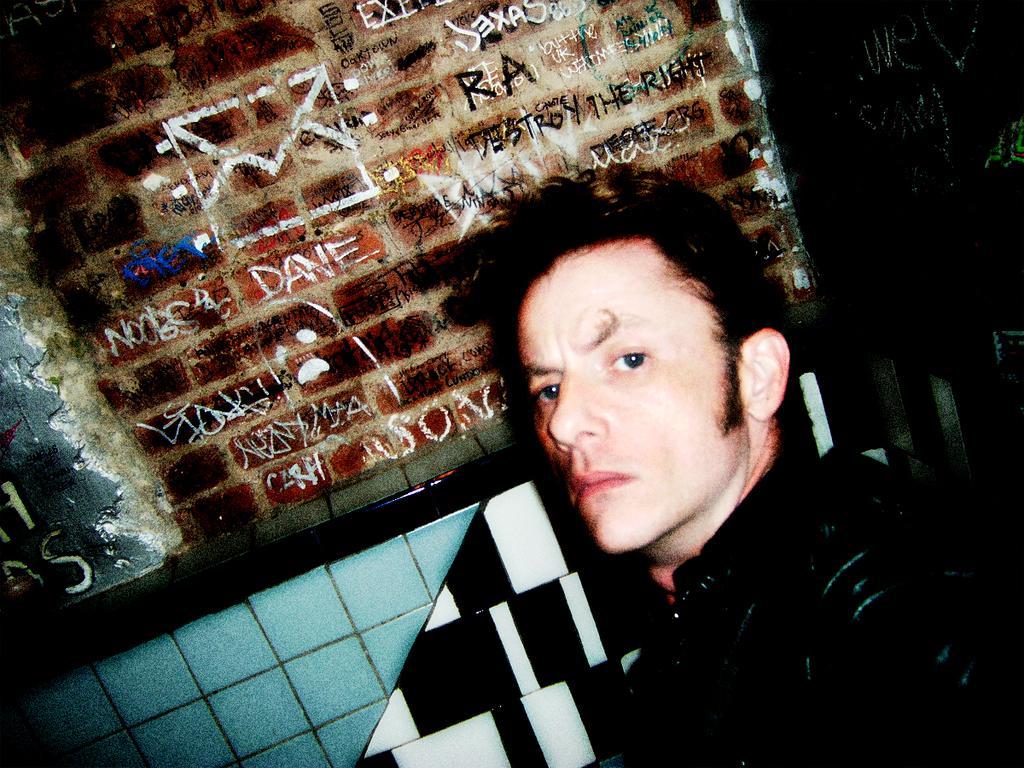How would you summarize this image in a sentence or two? In this picture one person is staring and something was written on the brick. 